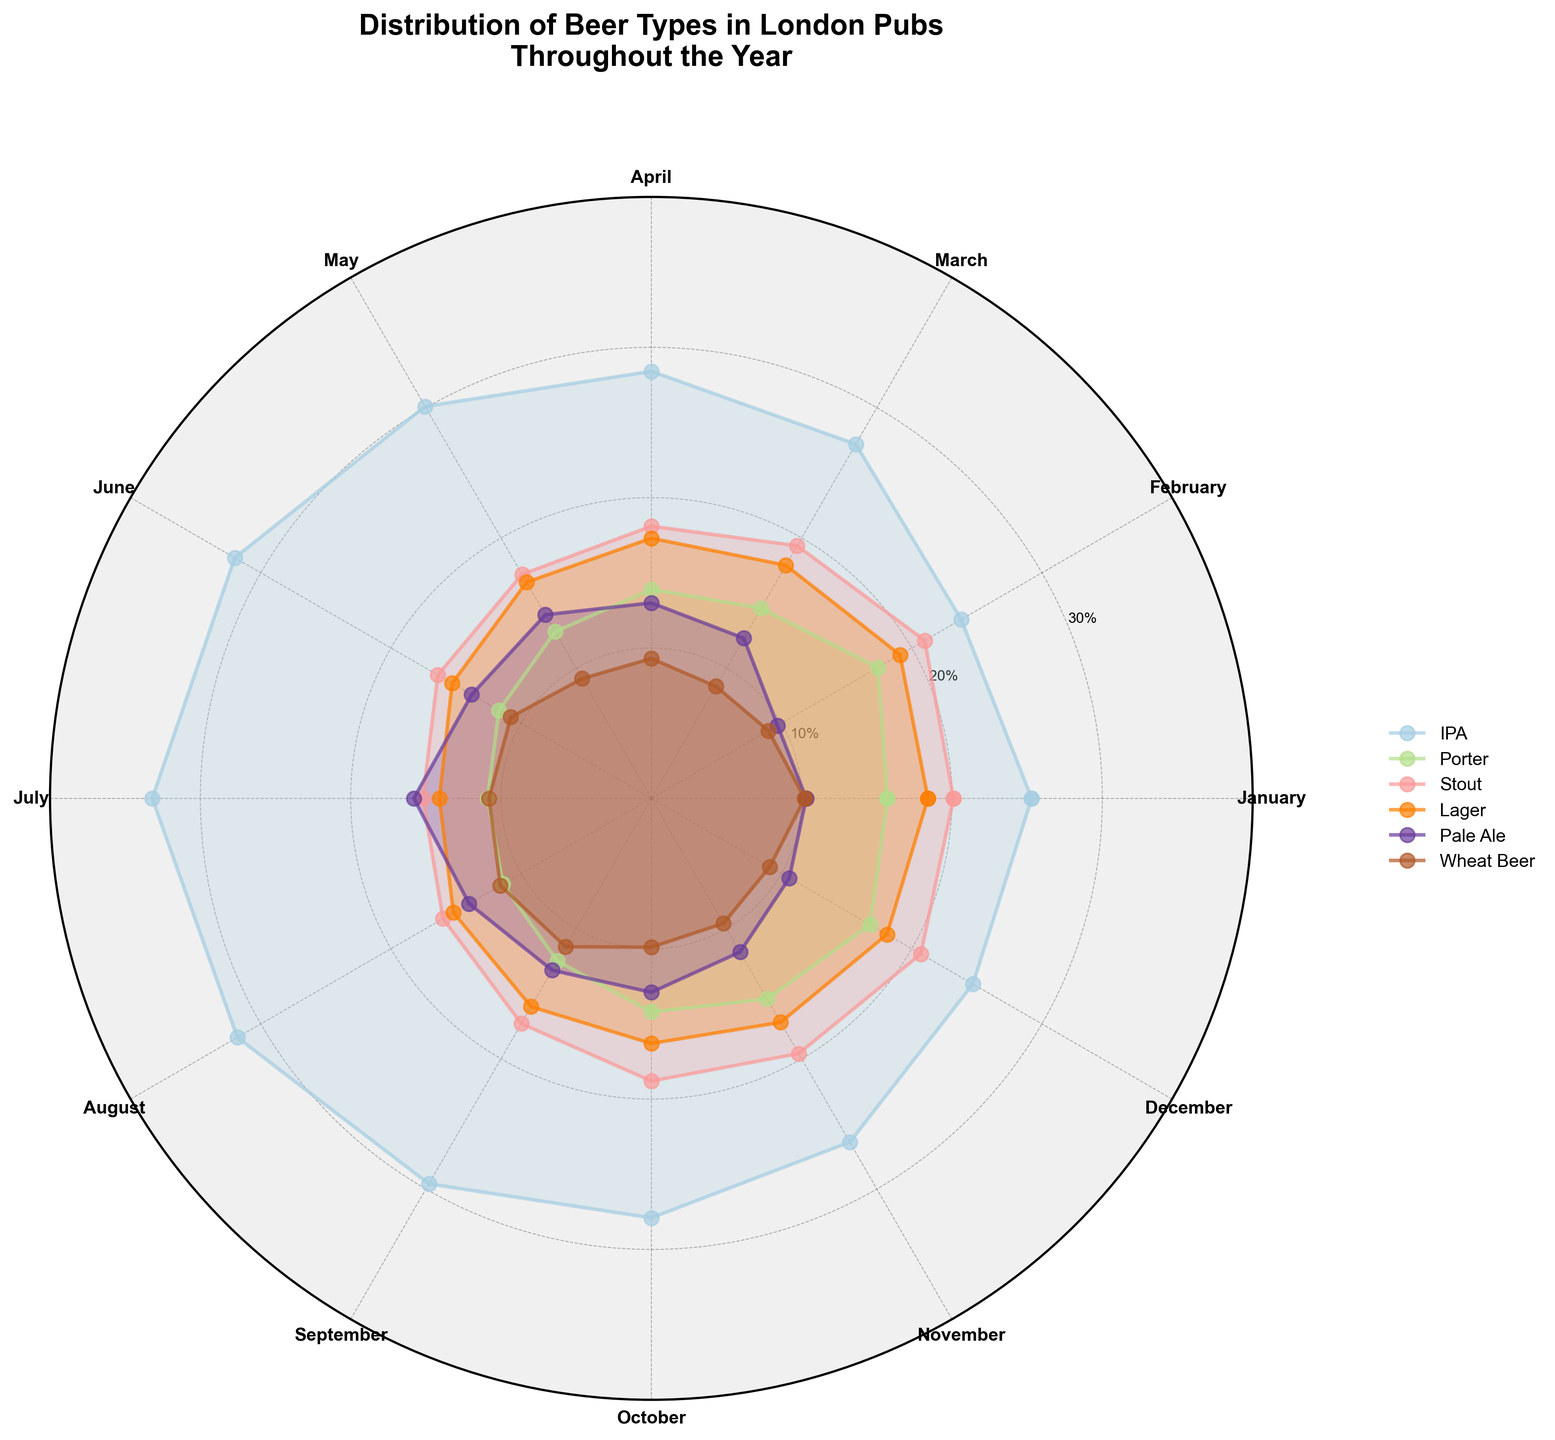What's the title of this chart? The title of the chart appears at the top and reads "Distribution of Beer Types in London Pubs Throughout the Year"
Answer: Distribution of Beer Types in London Pubs Throughout the Year How many beer types are displayed on the chart? According to the legend, there are 6 different beer types plotted on the chart
Answer: 6 Which beer type has the highest consumption in July? From the chart, the line corresponding to IPA extends furthest from the center in July, indicating it has the highest consumption in that month
Answer: IPA In which month is the consumption of Stout the highest? Looking at the Stout line, it extends furthest in December compared to other months
Answer: December What is the average consumption percentage of Lager across all months? Sum the Lager percentages: 18.4 + 19.1 + 17.9 + 17.3 + 16.6 + 15.3 + 14.1 + 15.2 + 16.0 + 16.3 + 17.2 + 18.1 = 201.5. Then, divide by 12 months: 201.5 / 12
Answer: 16.8% How does the consumption of Pale Ale in February compare to March? Compare the lengths of the Pale Ale lines for February and March; the value is higher in March (12.3) than in February (9.7)
Answer: Higher in March Which two months have the closest percentages for Porter? By observing the radial lengths for Porter, April (13.9) and August (11.4) are the most similar
Answer: April and August Which beer type shows an increase in consumption from January to June? Look at the lines between January and June; IPA shows a clear increase from 25.3 in January to 32.0 in June
Answer: IPA What's the trend of Wheat Beer consumption throughout the year? The lines for Wheat Beer remain relatively stable but have slight variations with the certain peaks and troughs, ending close to the starting value
Answer: Relatively stable with slight variations 